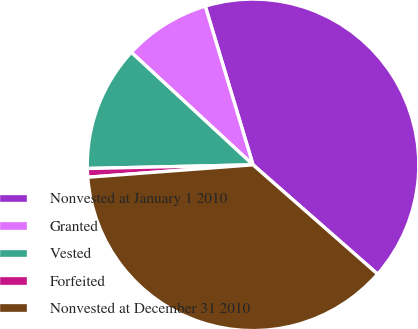Convert chart to OTSL. <chart><loc_0><loc_0><loc_500><loc_500><pie_chart><fcel>Nonvested at January 1 2010<fcel>Granted<fcel>Vested<fcel>Forfeited<fcel>Nonvested at December 31 2010<nl><fcel>41.12%<fcel>8.47%<fcel>12.23%<fcel>0.84%<fcel>37.35%<nl></chart> 